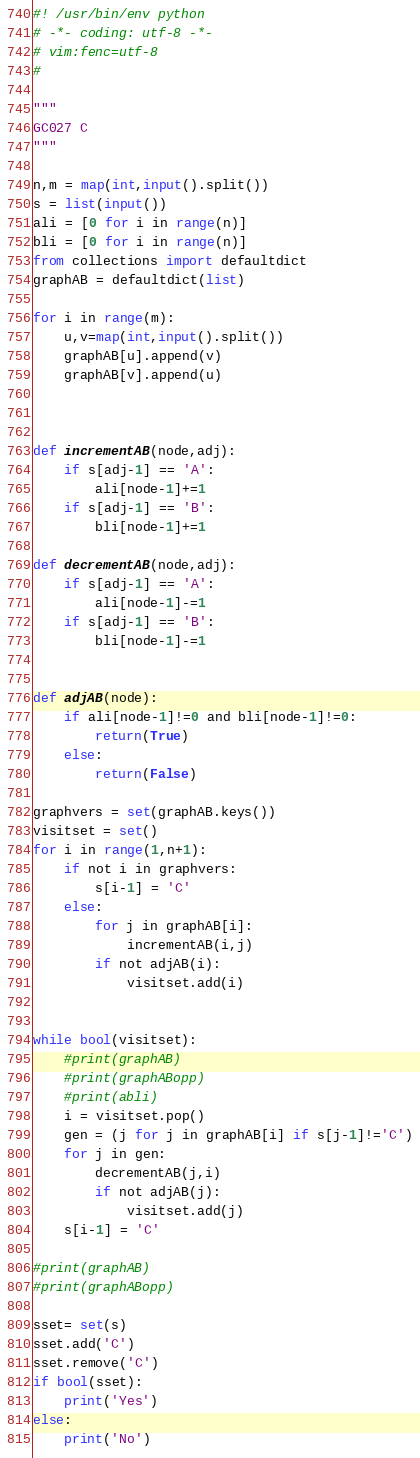Convert code to text. <code><loc_0><loc_0><loc_500><loc_500><_Python_>#! /usr/bin/env python
# -*- coding: utf-8 -*-
# vim:fenc=utf-8
#

"""
GC027 C
"""

n,m = map(int,input().split())
s = list(input())
ali = [0 for i in range(n)]
bli = [0 for i in range(n)]
from collections import defaultdict
graphAB = defaultdict(list)

for i in range(m):
    u,v=map(int,input().split())
    graphAB[u].append(v)
    graphAB[v].append(u)



def incrementAB(node,adj):
    if s[adj-1] == 'A':
        ali[node-1]+=1
    if s[adj-1] == 'B':
        bli[node-1]+=1

def decrementAB(node,adj):
    if s[adj-1] == 'A':
        ali[node-1]-=1
    if s[adj-1] == 'B':
        bli[node-1]-=1


def adjAB(node):
    if ali[node-1]!=0 and bli[node-1]!=0:
        return(True)
    else:
        return(False)

graphvers = set(graphAB.keys())
visitset = set()
for i in range(1,n+1):
    if not i in graphvers:
        s[i-1] = 'C'
    else:
        for j in graphAB[i]:
            incrementAB(i,j)
        if not adjAB(i):
            visitset.add(i)


while bool(visitset):
    #print(graphAB)
    #print(graphABopp)
    #print(abli)
    i = visitset.pop()
    gen = (j for j in graphAB[i] if s[j-1]!='C')
    for j in gen:
        decrementAB(j,i)
        if not adjAB(j):
            visitset.add(j)
    s[i-1] = 'C'

#print(graphAB)
#print(graphABopp)

sset= set(s)
sset.add('C')
sset.remove('C')
if bool(sset):
    print('Yes')
else:
    print('No')



</code> 